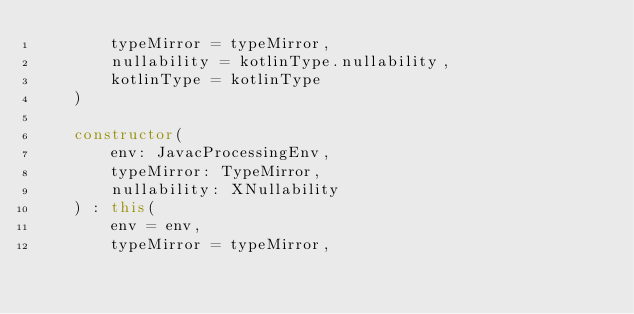<code> <loc_0><loc_0><loc_500><loc_500><_Kotlin_>        typeMirror = typeMirror,
        nullability = kotlinType.nullability,
        kotlinType = kotlinType
    )

    constructor(
        env: JavacProcessingEnv,
        typeMirror: TypeMirror,
        nullability: XNullability
    ) : this(
        env = env,
        typeMirror = typeMirror,</code> 